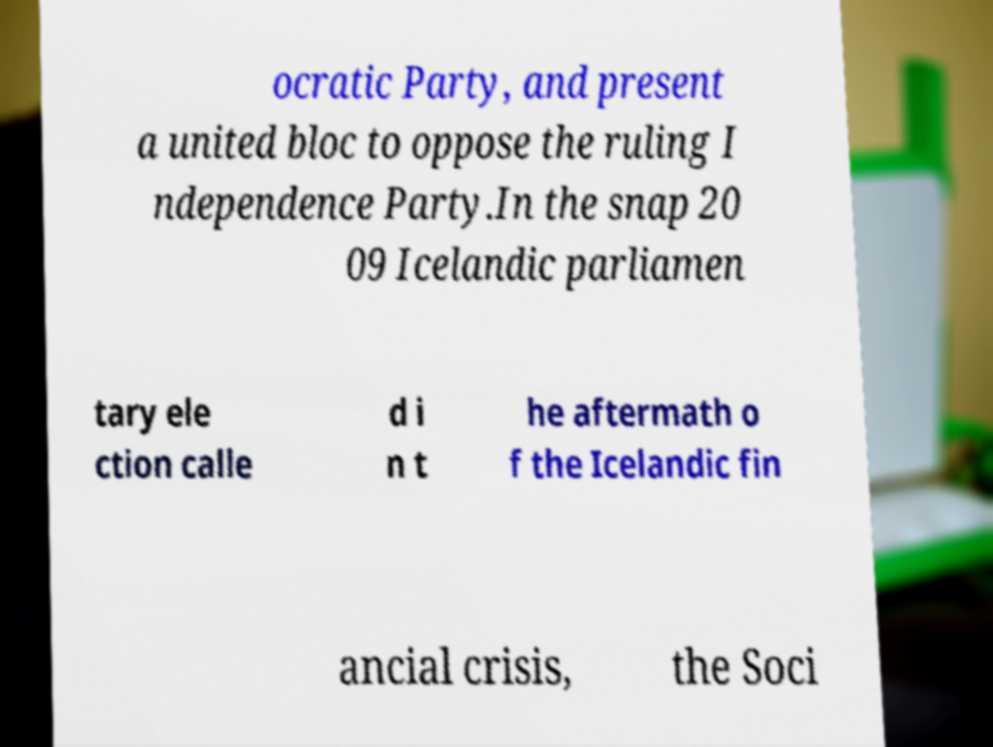What messages or text are displayed in this image? I need them in a readable, typed format. ocratic Party, and present a united bloc to oppose the ruling I ndependence Party.In the snap 20 09 Icelandic parliamen tary ele ction calle d i n t he aftermath o f the Icelandic fin ancial crisis, the Soci 